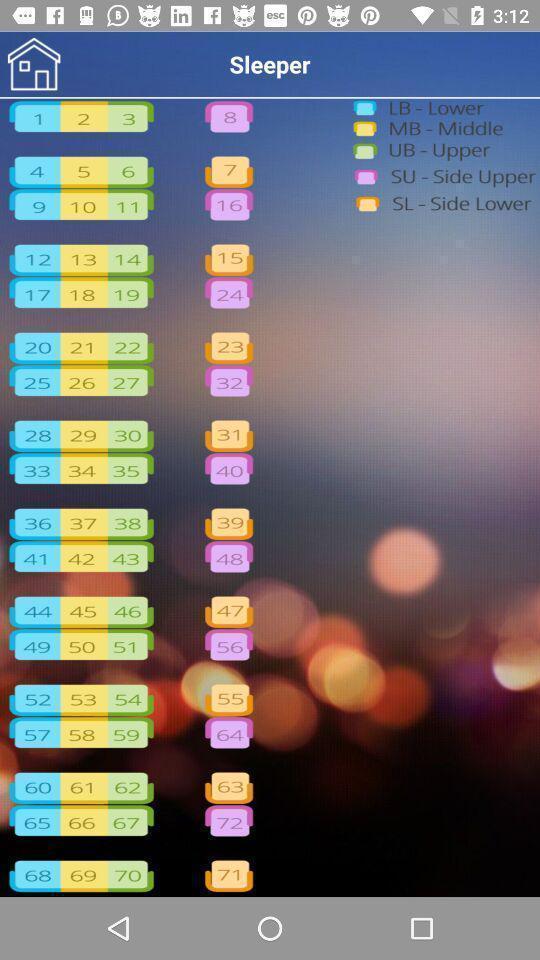What can you discern from this picture? Various vacant seats displayed in a travelling app. 